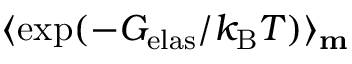Convert formula to latex. <formula><loc_0><loc_0><loc_500><loc_500>\langle \exp ( - G _ { e l a s } / k _ { B } T ) \rangle _ { m }</formula> 